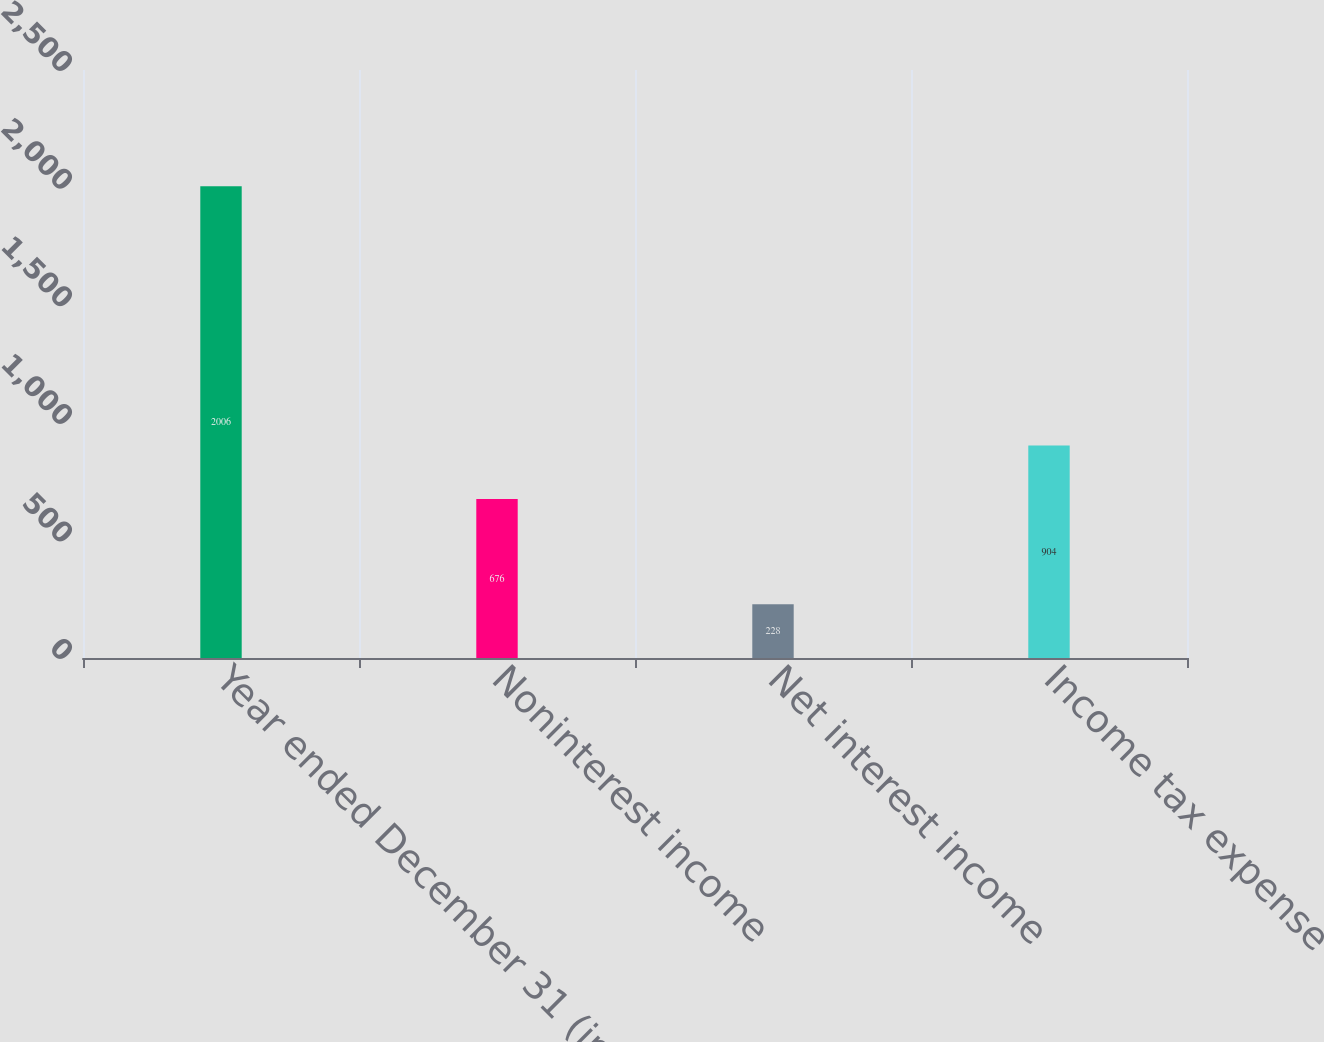<chart> <loc_0><loc_0><loc_500><loc_500><bar_chart><fcel>Year ended December 31 (in<fcel>Noninterest income<fcel>Net interest income<fcel>Income tax expense<nl><fcel>2006<fcel>676<fcel>228<fcel>904<nl></chart> 